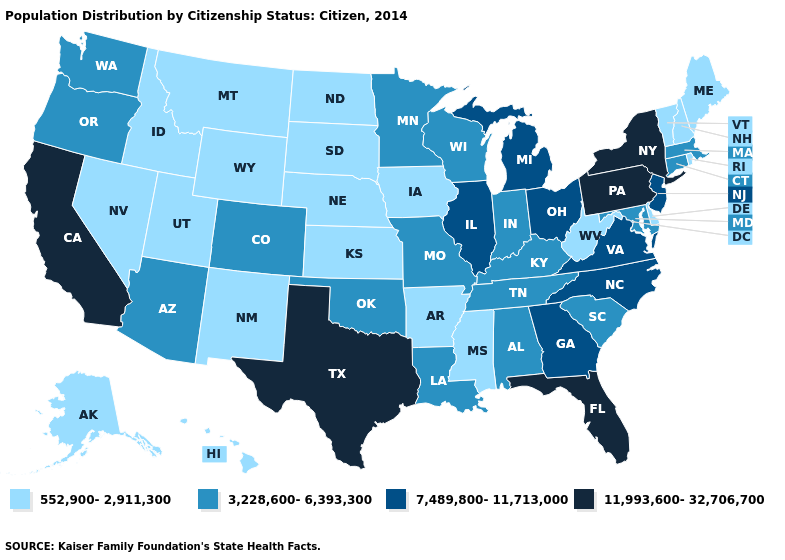Among the states that border West Virginia , which have the highest value?
Concise answer only. Pennsylvania. Does the map have missing data?
Answer briefly. No. Among the states that border Utah , which have the lowest value?
Short answer required. Idaho, Nevada, New Mexico, Wyoming. Among the states that border Oregon , does California have the lowest value?
Quick response, please. No. Among the states that border Tennessee , does Arkansas have the lowest value?
Concise answer only. Yes. Among the states that border Louisiana , does Texas have the highest value?
Write a very short answer. Yes. Does Washington have the same value as Indiana?
Write a very short answer. Yes. Among the states that border North Dakota , does South Dakota have the highest value?
Keep it brief. No. What is the value of New York?
Short answer required. 11,993,600-32,706,700. What is the value of Vermont?
Short answer required. 552,900-2,911,300. Name the states that have a value in the range 552,900-2,911,300?
Answer briefly. Alaska, Arkansas, Delaware, Hawaii, Idaho, Iowa, Kansas, Maine, Mississippi, Montana, Nebraska, Nevada, New Hampshire, New Mexico, North Dakota, Rhode Island, South Dakota, Utah, Vermont, West Virginia, Wyoming. What is the value of Alabama?
Short answer required. 3,228,600-6,393,300. Does Wyoming have the same value as Pennsylvania?
Quick response, please. No. Among the states that border Kansas , does Nebraska have the lowest value?
Short answer required. Yes. What is the value of Illinois?
Answer briefly. 7,489,800-11,713,000. 